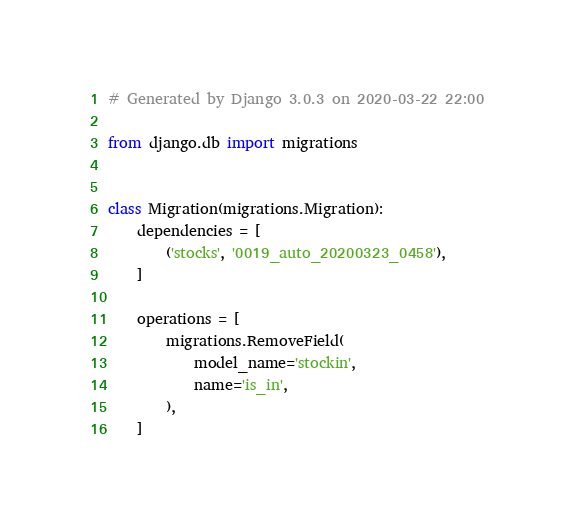Convert code to text. <code><loc_0><loc_0><loc_500><loc_500><_Python_># Generated by Django 3.0.3 on 2020-03-22 22:00

from django.db import migrations


class Migration(migrations.Migration):
    dependencies = [
        ('stocks', '0019_auto_20200323_0458'),
    ]

    operations = [
        migrations.RemoveField(
            model_name='stockin',
            name='is_in',
        ),
    ]
</code> 